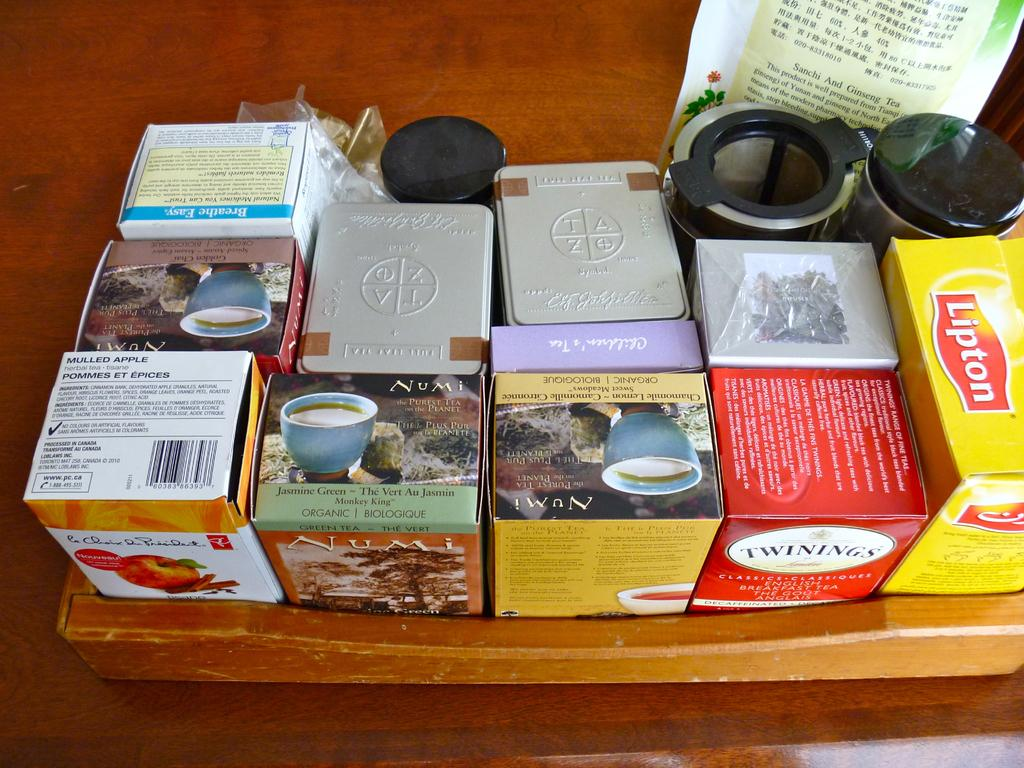<image>
Summarize the visual content of the image. A box of Lipton tea sits among many other tea boxes. 